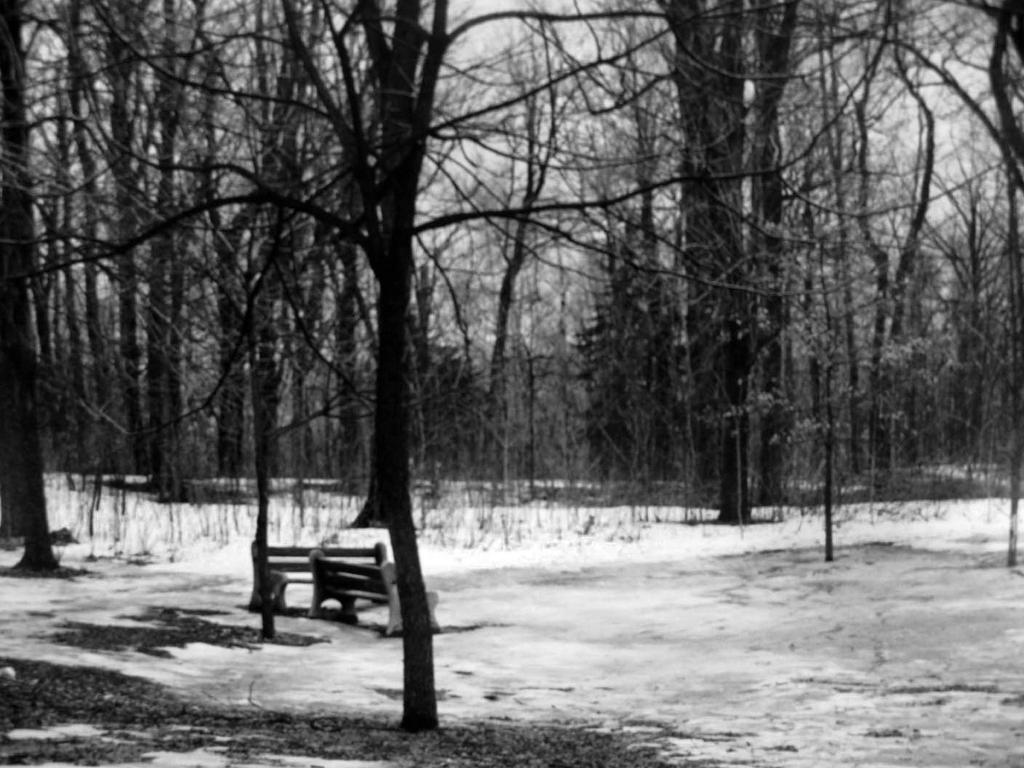Please provide a concise description of this image. In this image I can see two benches on the ground, trees and the sky. This image is taken may be in the forest. 